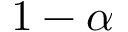<formula> <loc_0><loc_0><loc_500><loc_500>1 - \alpha</formula> 